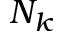<formula> <loc_0><loc_0><loc_500><loc_500>N _ { k }</formula> 